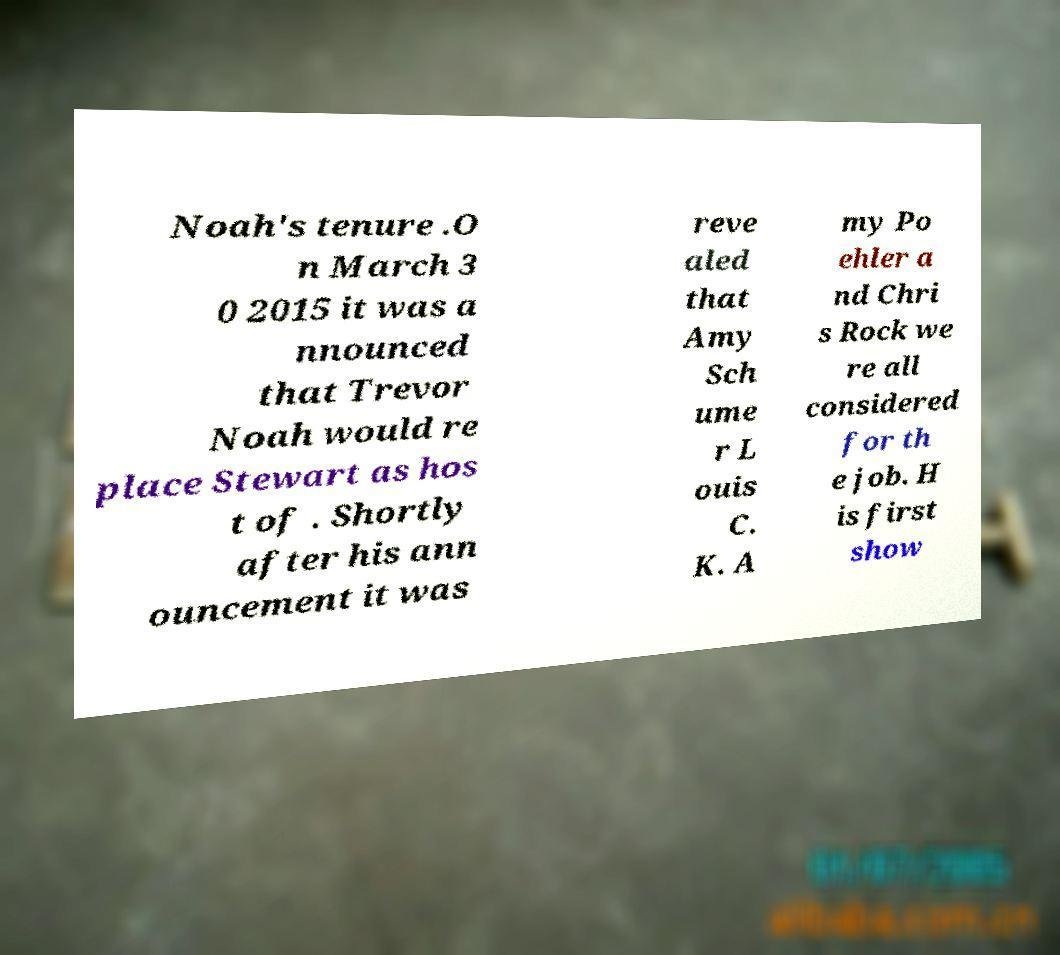There's text embedded in this image that I need extracted. Can you transcribe it verbatim? Noah's tenure .O n March 3 0 2015 it was a nnounced that Trevor Noah would re place Stewart as hos t of . Shortly after his ann ouncement it was reve aled that Amy Sch ume r L ouis C. K. A my Po ehler a nd Chri s Rock we re all considered for th e job. H is first show 